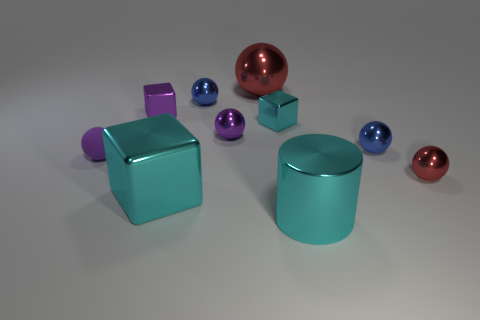What number of tiny cyan shiny spheres are there?
Offer a terse response. 0. What is the color of the tiny metallic ball behind the block to the right of the cube that is in front of the rubber ball?
Provide a succinct answer. Blue. Is the color of the shiny cylinder the same as the big cube?
Your answer should be compact. Yes. How many tiny metal objects are both to the right of the cylinder and on the left side of the small red shiny sphere?
Your answer should be compact. 1. What number of shiny things are large things or purple blocks?
Keep it short and to the point. 4. What is the material of the object on the left side of the purple metallic thing that is on the left side of the large cyan shiny block?
Make the answer very short. Rubber. There is a small thing that is the same color as the big block; what is its shape?
Provide a succinct answer. Cube. What is the shape of the red object that is the same size as the matte sphere?
Give a very brief answer. Sphere. Is the number of purple rubber objects less than the number of small yellow rubber blocks?
Provide a short and direct response. No. Are there any shiny objects on the right side of the big red thing that is right of the small rubber object?
Make the answer very short. Yes. 